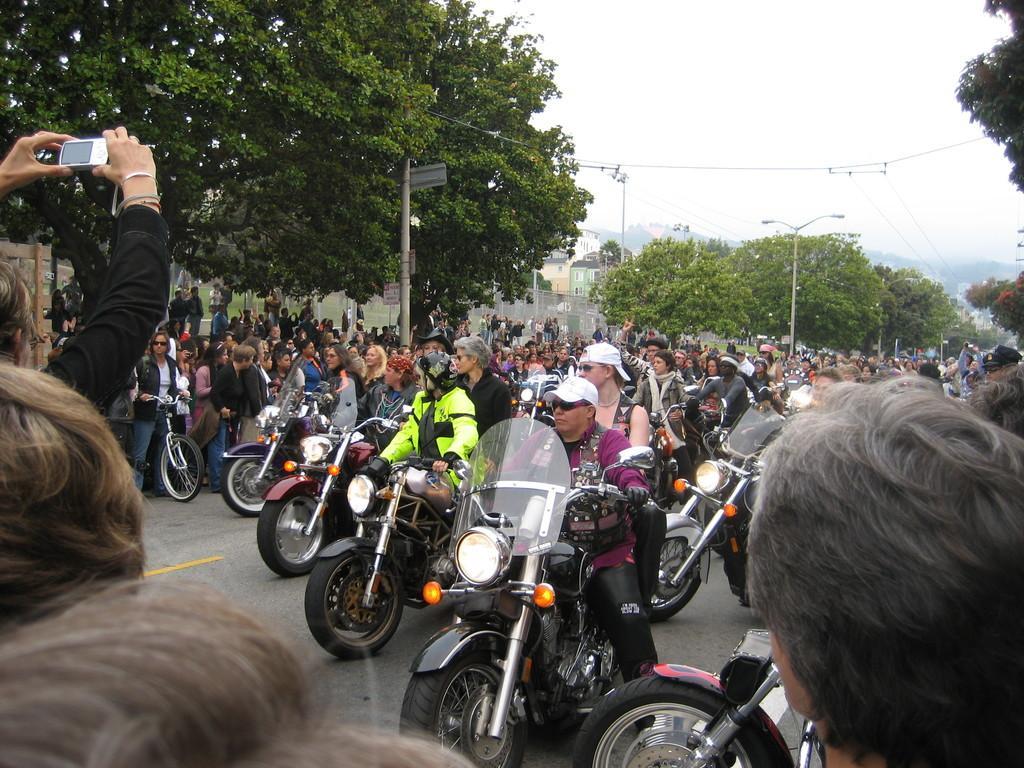Please provide a concise description of this image. There are few persons on the vehicles on the road. At the bottom and on the left side we can see few persons and among them a person is holding a camera in the hands. In the background there are few persons, trees, poles, buildings, wires and clouds in the sky. 